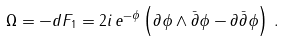<formula> <loc_0><loc_0><loc_500><loc_500>\Omega = - d F _ { 1 } = 2 i \, e ^ { - \phi } \left ( \partial \phi \wedge \bar { \partial } \phi - \partial \bar { \partial } \phi \right ) \, .</formula> 